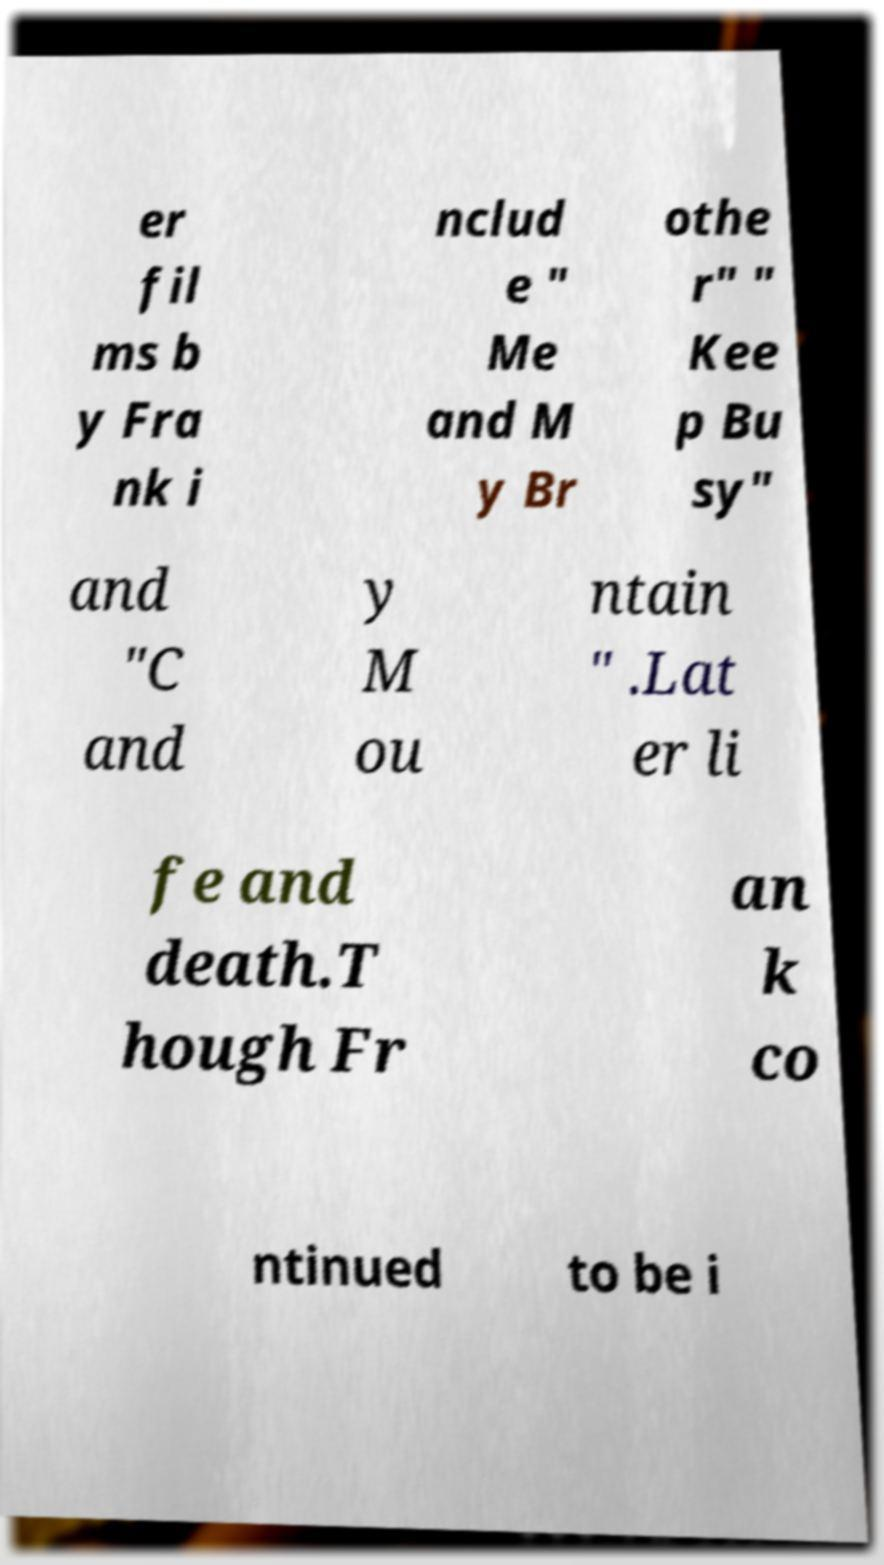What messages or text are displayed in this image? I need them in a readable, typed format. er fil ms b y Fra nk i nclud e " Me and M y Br othe r" " Kee p Bu sy" and "C and y M ou ntain " .Lat er li fe and death.T hough Fr an k co ntinued to be i 